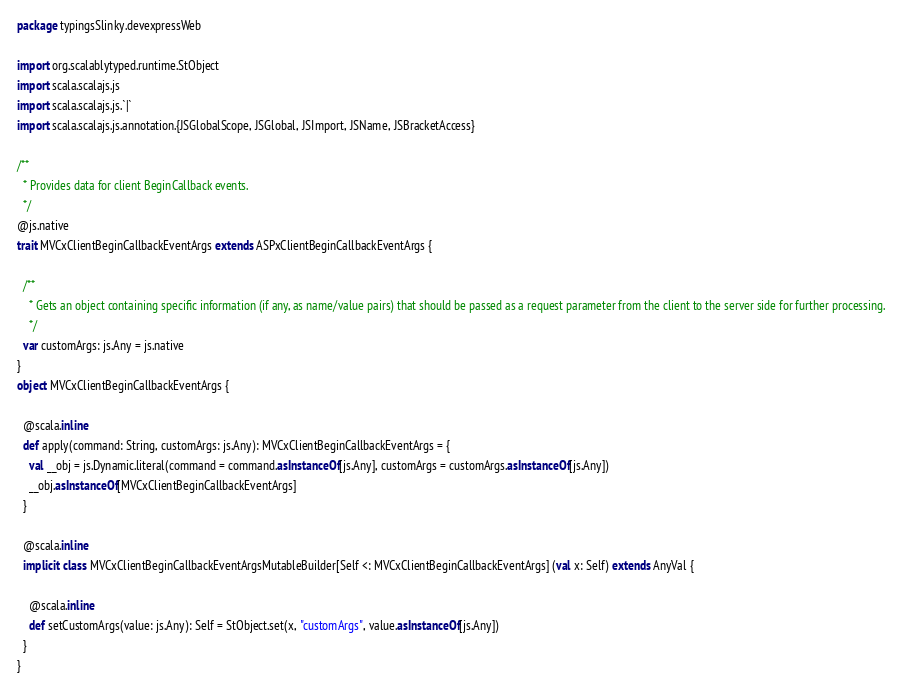Convert code to text. <code><loc_0><loc_0><loc_500><loc_500><_Scala_>package typingsSlinky.devexpressWeb

import org.scalablytyped.runtime.StObject
import scala.scalajs.js
import scala.scalajs.js.`|`
import scala.scalajs.js.annotation.{JSGlobalScope, JSGlobal, JSImport, JSName, JSBracketAccess}

/**
  * Provides data for client BeginCallback events.
  */
@js.native
trait MVCxClientBeginCallbackEventArgs extends ASPxClientBeginCallbackEventArgs {
  
  /**
    * Gets an object containing specific information (if any, as name/value pairs) that should be passed as a request parameter from the client to the server side for further processing.
    */
  var customArgs: js.Any = js.native
}
object MVCxClientBeginCallbackEventArgs {
  
  @scala.inline
  def apply(command: String, customArgs: js.Any): MVCxClientBeginCallbackEventArgs = {
    val __obj = js.Dynamic.literal(command = command.asInstanceOf[js.Any], customArgs = customArgs.asInstanceOf[js.Any])
    __obj.asInstanceOf[MVCxClientBeginCallbackEventArgs]
  }
  
  @scala.inline
  implicit class MVCxClientBeginCallbackEventArgsMutableBuilder[Self <: MVCxClientBeginCallbackEventArgs] (val x: Self) extends AnyVal {
    
    @scala.inline
    def setCustomArgs(value: js.Any): Self = StObject.set(x, "customArgs", value.asInstanceOf[js.Any])
  }
}
</code> 